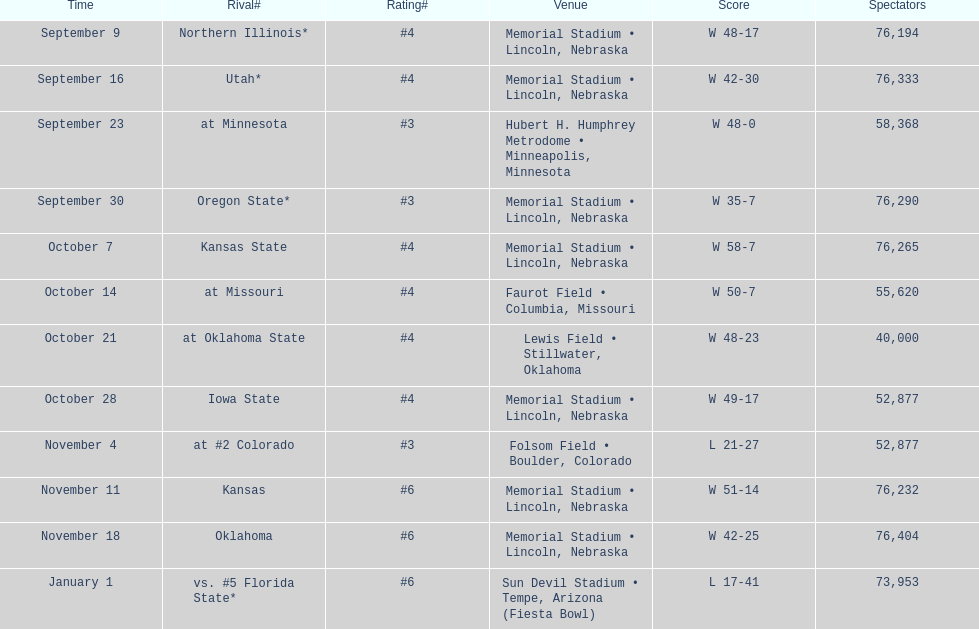What is the next site listed after lewis field? Memorial Stadium • Lincoln, Nebraska. 